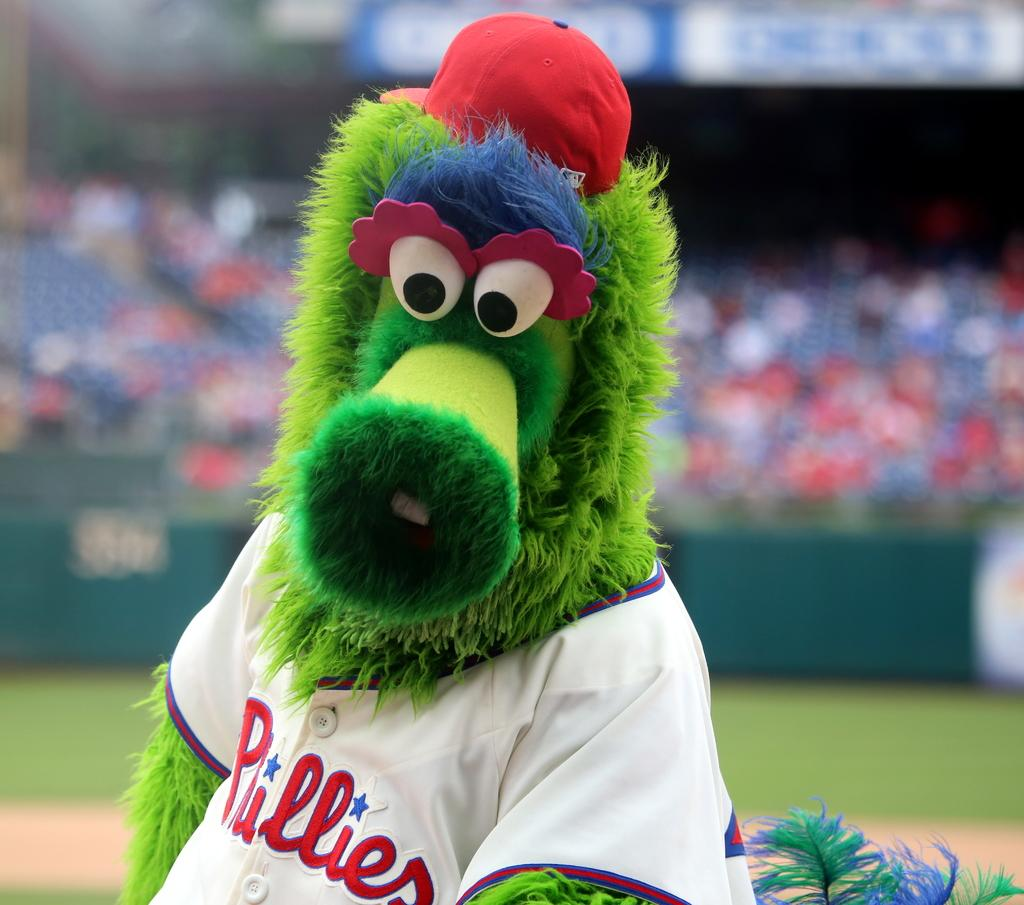<image>
Describe the image concisely. a person with a Phillies outfit on at a game 